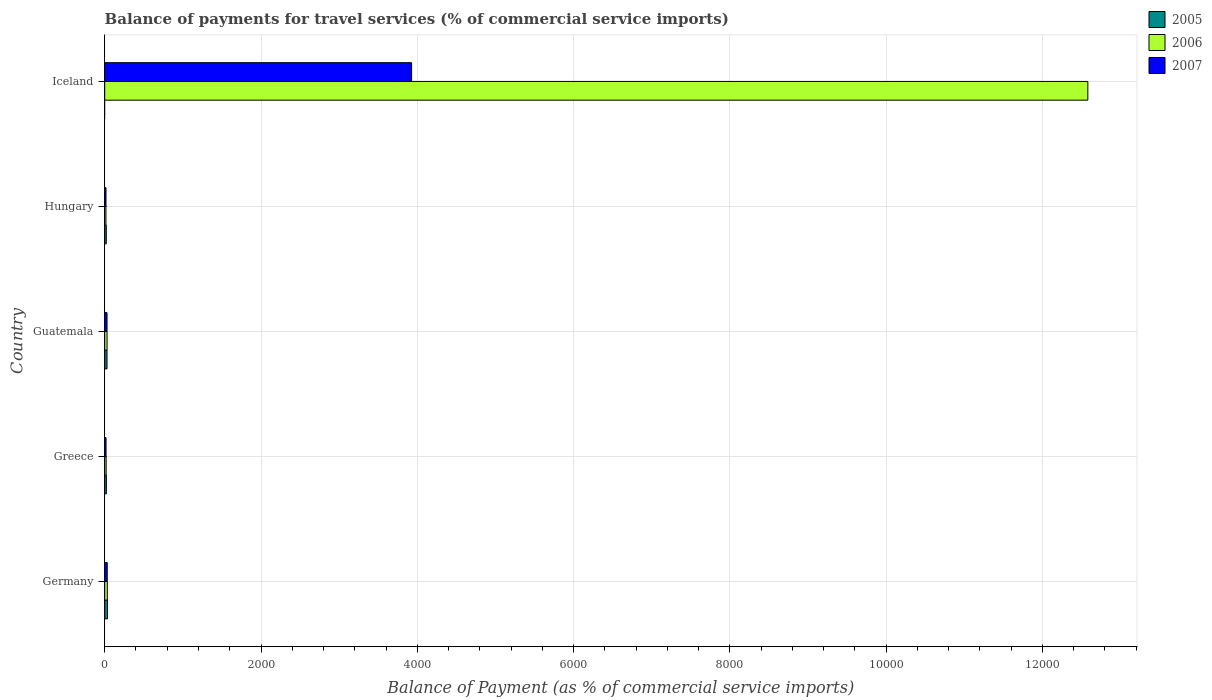How many groups of bars are there?
Offer a very short reply. 5. How many bars are there on the 2nd tick from the top?
Offer a terse response. 3. In how many cases, is the number of bars for a given country not equal to the number of legend labels?
Offer a very short reply. 1. What is the balance of payments for travel services in 2005 in Greece?
Keep it short and to the point. 21.01. Across all countries, what is the maximum balance of payments for travel services in 2005?
Keep it short and to the point. 35.65. What is the total balance of payments for travel services in 2007 in the graph?
Ensure brevity in your answer.  4022.27. What is the difference between the balance of payments for travel services in 2007 in Guatemala and that in Hungary?
Provide a short and direct response. 13.29. What is the difference between the balance of payments for travel services in 2006 in Germany and the balance of payments for travel services in 2007 in Iceland?
Make the answer very short. -3893.86. What is the average balance of payments for travel services in 2007 per country?
Provide a short and direct response. 804.45. What is the difference between the balance of payments for travel services in 2006 and balance of payments for travel services in 2007 in Greece?
Offer a terse response. 1.38. In how many countries, is the balance of payments for travel services in 2005 greater than 800 %?
Your response must be concise. 0. What is the ratio of the balance of payments for travel services in 2007 in Guatemala to that in Hungary?
Make the answer very short. 1.81. Is the difference between the balance of payments for travel services in 2006 in Guatemala and Iceland greater than the difference between the balance of payments for travel services in 2007 in Guatemala and Iceland?
Your answer should be very brief. No. What is the difference between the highest and the second highest balance of payments for travel services in 2005?
Your response must be concise. 6.2. What is the difference between the highest and the lowest balance of payments for travel services in 2007?
Make the answer very short. 3910.73. In how many countries, is the balance of payments for travel services in 2007 greater than the average balance of payments for travel services in 2007 taken over all countries?
Provide a succinct answer. 1. Is it the case that in every country, the sum of the balance of payments for travel services in 2005 and balance of payments for travel services in 2007 is greater than the balance of payments for travel services in 2006?
Provide a succinct answer. No. Are all the bars in the graph horizontal?
Offer a terse response. Yes. How many countries are there in the graph?
Your response must be concise. 5. Does the graph contain any zero values?
Your answer should be very brief. Yes. Where does the legend appear in the graph?
Your answer should be compact. Top right. How are the legend labels stacked?
Give a very brief answer. Vertical. What is the title of the graph?
Your answer should be compact. Balance of payments for travel services (% of commercial service imports). Does "1988" appear as one of the legend labels in the graph?
Give a very brief answer. No. What is the label or title of the X-axis?
Offer a terse response. Balance of Payment (as % of commercial service imports). What is the label or title of the Y-axis?
Your answer should be compact. Country. What is the Balance of Payment (as % of commercial service imports) in 2005 in Germany?
Your answer should be compact. 35.65. What is the Balance of Payment (as % of commercial service imports) in 2006 in Germany?
Provide a succinct answer. 33.19. What is the Balance of Payment (as % of commercial service imports) of 2007 in Germany?
Keep it short and to the point. 32.28. What is the Balance of Payment (as % of commercial service imports) in 2005 in Greece?
Offer a very short reply. 21.01. What is the Balance of Payment (as % of commercial service imports) in 2006 in Greece?
Give a very brief answer. 18.4. What is the Balance of Payment (as % of commercial service imports) of 2007 in Greece?
Offer a very short reply. 17.02. What is the Balance of Payment (as % of commercial service imports) in 2005 in Guatemala?
Ensure brevity in your answer.  29.45. What is the Balance of Payment (as % of commercial service imports) in 2006 in Guatemala?
Provide a succinct answer. 30.09. What is the Balance of Payment (as % of commercial service imports) of 2007 in Guatemala?
Offer a very short reply. 29.61. What is the Balance of Payment (as % of commercial service imports) of 2005 in Hungary?
Ensure brevity in your answer.  20.04. What is the Balance of Payment (as % of commercial service imports) of 2006 in Hungary?
Your response must be concise. 15.72. What is the Balance of Payment (as % of commercial service imports) in 2007 in Hungary?
Ensure brevity in your answer.  16.32. What is the Balance of Payment (as % of commercial service imports) in 2005 in Iceland?
Ensure brevity in your answer.  0. What is the Balance of Payment (as % of commercial service imports) of 2006 in Iceland?
Provide a succinct answer. 1.26e+04. What is the Balance of Payment (as % of commercial service imports) of 2007 in Iceland?
Ensure brevity in your answer.  3927.05. Across all countries, what is the maximum Balance of Payment (as % of commercial service imports) in 2005?
Your answer should be compact. 35.65. Across all countries, what is the maximum Balance of Payment (as % of commercial service imports) of 2006?
Your response must be concise. 1.26e+04. Across all countries, what is the maximum Balance of Payment (as % of commercial service imports) in 2007?
Your response must be concise. 3927.05. Across all countries, what is the minimum Balance of Payment (as % of commercial service imports) of 2006?
Provide a short and direct response. 15.72. Across all countries, what is the minimum Balance of Payment (as % of commercial service imports) in 2007?
Give a very brief answer. 16.32. What is the total Balance of Payment (as % of commercial service imports) of 2005 in the graph?
Provide a short and direct response. 106.16. What is the total Balance of Payment (as % of commercial service imports) in 2006 in the graph?
Provide a short and direct response. 1.27e+04. What is the total Balance of Payment (as % of commercial service imports) in 2007 in the graph?
Your answer should be compact. 4022.27. What is the difference between the Balance of Payment (as % of commercial service imports) in 2005 in Germany and that in Greece?
Your answer should be very brief. 14.64. What is the difference between the Balance of Payment (as % of commercial service imports) of 2006 in Germany and that in Greece?
Ensure brevity in your answer.  14.79. What is the difference between the Balance of Payment (as % of commercial service imports) of 2007 in Germany and that in Greece?
Your response must be concise. 15.27. What is the difference between the Balance of Payment (as % of commercial service imports) in 2005 in Germany and that in Guatemala?
Your answer should be compact. 6.2. What is the difference between the Balance of Payment (as % of commercial service imports) of 2006 in Germany and that in Guatemala?
Provide a short and direct response. 3.1. What is the difference between the Balance of Payment (as % of commercial service imports) of 2007 in Germany and that in Guatemala?
Provide a succinct answer. 2.67. What is the difference between the Balance of Payment (as % of commercial service imports) in 2005 in Germany and that in Hungary?
Keep it short and to the point. 15.61. What is the difference between the Balance of Payment (as % of commercial service imports) of 2006 in Germany and that in Hungary?
Provide a succinct answer. 17.47. What is the difference between the Balance of Payment (as % of commercial service imports) in 2007 in Germany and that in Hungary?
Keep it short and to the point. 15.97. What is the difference between the Balance of Payment (as % of commercial service imports) of 2006 in Germany and that in Iceland?
Provide a short and direct response. -1.25e+04. What is the difference between the Balance of Payment (as % of commercial service imports) in 2007 in Germany and that in Iceland?
Keep it short and to the point. -3894.76. What is the difference between the Balance of Payment (as % of commercial service imports) in 2005 in Greece and that in Guatemala?
Your response must be concise. -8.44. What is the difference between the Balance of Payment (as % of commercial service imports) of 2006 in Greece and that in Guatemala?
Ensure brevity in your answer.  -11.69. What is the difference between the Balance of Payment (as % of commercial service imports) of 2007 in Greece and that in Guatemala?
Offer a terse response. -12.59. What is the difference between the Balance of Payment (as % of commercial service imports) in 2005 in Greece and that in Hungary?
Offer a very short reply. 0.97. What is the difference between the Balance of Payment (as % of commercial service imports) of 2006 in Greece and that in Hungary?
Provide a succinct answer. 2.68. What is the difference between the Balance of Payment (as % of commercial service imports) in 2007 in Greece and that in Hungary?
Your response must be concise. 0.7. What is the difference between the Balance of Payment (as % of commercial service imports) of 2006 in Greece and that in Iceland?
Your answer should be compact. -1.26e+04. What is the difference between the Balance of Payment (as % of commercial service imports) in 2007 in Greece and that in Iceland?
Make the answer very short. -3910.03. What is the difference between the Balance of Payment (as % of commercial service imports) in 2005 in Guatemala and that in Hungary?
Provide a succinct answer. 9.41. What is the difference between the Balance of Payment (as % of commercial service imports) of 2006 in Guatemala and that in Hungary?
Your answer should be compact. 14.37. What is the difference between the Balance of Payment (as % of commercial service imports) in 2007 in Guatemala and that in Hungary?
Provide a short and direct response. 13.29. What is the difference between the Balance of Payment (as % of commercial service imports) of 2006 in Guatemala and that in Iceland?
Give a very brief answer. -1.26e+04. What is the difference between the Balance of Payment (as % of commercial service imports) of 2007 in Guatemala and that in Iceland?
Offer a very short reply. -3897.44. What is the difference between the Balance of Payment (as % of commercial service imports) in 2006 in Hungary and that in Iceland?
Your response must be concise. -1.26e+04. What is the difference between the Balance of Payment (as % of commercial service imports) in 2007 in Hungary and that in Iceland?
Provide a succinct answer. -3910.73. What is the difference between the Balance of Payment (as % of commercial service imports) in 2005 in Germany and the Balance of Payment (as % of commercial service imports) in 2006 in Greece?
Provide a short and direct response. 17.25. What is the difference between the Balance of Payment (as % of commercial service imports) in 2005 in Germany and the Balance of Payment (as % of commercial service imports) in 2007 in Greece?
Ensure brevity in your answer.  18.63. What is the difference between the Balance of Payment (as % of commercial service imports) in 2006 in Germany and the Balance of Payment (as % of commercial service imports) in 2007 in Greece?
Your answer should be compact. 16.17. What is the difference between the Balance of Payment (as % of commercial service imports) of 2005 in Germany and the Balance of Payment (as % of commercial service imports) of 2006 in Guatemala?
Keep it short and to the point. 5.56. What is the difference between the Balance of Payment (as % of commercial service imports) of 2005 in Germany and the Balance of Payment (as % of commercial service imports) of 2007 in Guatemala?
Your answer should be very brief. 6.04. What is the difference between the Balance of Payment (as % of commercial service imports) of 2006 in Germany and the Balance of Payment (as % of commercial service imports) of 2007 in Guatemala?
Keep it short and to the point. 3.58. What is the difference between the Balance of Payment (as % of commercial service imports) of 2005 in Germany and the Balance of Payment (as % of commercial service imports) of 2006 in Hungary?
Your answer should be compact. 19.93. What is the difference between the Balance of Payment (as % of commercial service imports) in 2005 in Germany and the Balance of Payment (as % of commercial service imports) in 2007 in Hungary?
Offer a very short reply. 19.34. What is the difference between the Balance of Payment (as % of commercial service imports) in 2006 in Germany and the Balance of Payment (as % of commercial service imports) in 2007 in Hungary?
Make the answer very short. 16.87. What is the difference between the Balance of Payment (as % of commercial service imports) in 2005 in Germany and the Balance of Payment (as % of commercial service imports) in 2006 in Iceland?
Your answer should be compact. -1.25e+04. What is the difference between the Balance of Payment (as % of commercial service imports) in 2005 in Germany and the Balance of Payment (as % of commercial service imports) in 2007 in Iceland?
Offer a very short reply. -3891.4. What is the difference between the Balance of Payment (as % of commercial service imports) of 2006 in Germany and the Balance of Payment (as % of commercial service imports) of 2007 in Iceland?
Make the answer very short. -3893.86. What is the difference between the Balance of Payment (as % of commercial service imports) of 2005 in Greece and the Balance of Payment (as % of commercial service imports) of 2006 in Guatemala?
Ensure brevity in your answer.  -9.08. What is the difference between the Balance of Payment (as % of commercial service imports) in 2005 in Greece and the Balance of Payment (as % of commercial service imports) in 2007 in Guatemala?
Provide a succinct answer. -8.6. What is the difference between the Balance of Payment (as % of commercial service imports) of 2006 in Greece and the Balance of Payment (as % of commercial service imports) of 2007 in Guatemala?
Your response must be concise. -11.21. What is the difference between the Balance of Payment (as % of commercial service imports) of 2005 in Greece and the Balance of Payment (as % of commercial service imports) of 2006 in Hungary?
Give a very brief answer. 5.29. What is the difference between the Balance of Payment (as % of commercial service imports) of 2005 in Greece and the Balance of Payment (as % of commercial service imports) of 2007 in Hungary?
Your answer should be very brief. 4.69. What is the difference between the Balance of Payment (as % of commercial service imports) in 2006 in Greece and the Balance of Payment (as % of commercial service imports) in 2007 in Hungary?
Your response must be concise. 2.08. What is the difference between the Balance of Payment (as % of commercial service imports) of 2005 in Greece and the Balance of Payment (as % of commercial service imports) of 2006 in Iceland?
Provide a short and direct response. -1.26e+04. What is the difference between the Balance of Payment (as % of commercial service imports) in 2005 in Greece and the Balance of Payment (as % of commercial service imports) in 2007 in Iceland?
Keep it short and to the point. -3906.04. What is the difference between the Balance of Payment (as % of commercial service imports) of 2006 in Greece and the Balance of Payment (as % of commercial service imports) of 2007 in Iceland?
Keep it short and to the point. -3908.65. What is the difference between the Balance of Payment (as % of commercial service imports) of 2005 in Guatemala and the Balance of Payment (as % of commercial service imports) of 2006 in Hungary?
Offer a very short reply. 13.73. What is the difference between the Balance of Payment (as % of commercial service imports) in 2005 in Guatemala and the Balance of Payment (as % of commercial service imports) in 2007 in Hungary?
Your answer should be very brief. 13.13. What is the difference between the Balance of Payment (as % of commercial service imports) of 2006 in Guatemala and the Balance of Payment (as % of commercial service imports) of 2007 in Hungary?
Your response must be concise. 13.77. What is the difference between the Balance of Payment (as % of commercial service imports) in 2005 in Guatemala and the Balance of Payment (as % of commercial service imports) in 2006 in Iceland?
Ensure brevity in your answer.  -1.26e+04. What is the difference between the Balance of Payment (as % of commercial service imports) of 2005 in Guatemala and the Balance of Payment (as % of commercial service imports) of 2007 in Iceland?
Keep it short and to the point. -3897.6. What is the difference between the Balance of Payment (as % of commercial service imports) in 2006 in Guatemala and the Balance of Payment (as % of commercial service imports) in 2007 in Iceland?
Give a very brief answer. -3896.96. What is the difference between the Balance of Payment (as % of commercial service imports) of 2005 in Hungary and the Balance of Payment (as % of commercial service imports) of 2006 in Iceland?
Offer a terse response. -1.26e+04. What is the difference between the Balance of Payment (as % of commercial service imports) in 2005 in Hungary and the Balance of Payment (as % of commercial service imports) in 2007 in Iceland?
Your answer should be compact. -3907.01. What is the difference between the Balance of Payment (as % of commercial service imports) in 2006 in Hungary and the Balance of Payment (as % of commercial service imports) in 2007 in Iceland?
Keep it short and to the point. -3911.32. What is the average Balance of Payment (as % of commercial service imports) of 2005 per country?
Offer a terse response. 21.23. What is the average Balance of Payment (as % of commercial service imports) in 2006 per country?
Your response must be concise. 2535.76. What is the average Balance of Payment (as % of commercial service imports) of 2007 per country?
Offer a terse response. 804.45. What is the difference between the Balance of Payment (as % of commercial service imports) of 2005 and Balance of Payment (as % of commercial service imports) of 2006 in Germany?
Ensure brevity in your answer.  2.46. What is the difference between the Balance of Payment (as % of commercial service imports) in 2005 and Balance of Payment (as % of commercial service imports) in 2007 in Germany?
Ensure brevity in your answer.  3.37. What is the difference between the Balance of Payment (as % of commercial service imports) in 2006 and Balance of Payment (as % of commercial service imports) in 2007 in Germany?
Keep it short and to the point. 0.91. What is the difference between the Balance of Payment (as % of commercial service imports) in 2005 and Balance of Payment (as % of commercial service imports) in 2006 in Greece?
Offer a terse response. 2.61. What is the difference between the Balance of Payment (as % of commercial service imports) of 2005 and Balance of Payment (as % of commercial service imports) of 2007 in Greece?
Offer a very short reply. 3.99. What is the difference between the Balance of Payment (as % of commercial service imports) of 2006 and Balance of Payment (as % of commercial service imports) of 2007 in Greece?
Keep it short and to the point. 1.38. What is the difference between the Balance of Payment (as % of commercial service imports) of 2005 and Balance of Payment (as % of commercial service imports) of 2006 in Guatemala?
Your answer should be compact. -0.64. What is the difference between the Balance of Payment (as % of commercial service imports) in 2005 and Balance of Payment (as % of commercial service imports) in 2007 in Guatemala?
Give a very brief answer. -0.16. What is the difference between the Balance of Payment (as % of commercial service imports) of 2006 and Balance of Payment (as % of commercial service imports) of 2007 in Guatemala?
Give a very brief answer. 0.48. What is the difference between the Balance of Payment (as % of commercial service imports) of 2005 and Balance of Payment (as % of commercial service imports) of 2006 in Hungary?
Provide a succinct answer. 4.32. What is the difference between the Balance of Payment (as % of commercial service imports) of 2005 and Balance of Payment (as % of commercial service imports) of 2007 in Hungary?
Provide a succinct answer. 3.73. What is the difference between the Balance of Payment (as % of commercial service imports) in 2006 and Balance of Payment (as % of commercial service imports) in 2007 in Hungary?
Make the answer very short. -0.59. What is the difference between the Balance of Payment (as % of commercial service imports) in 2006 and Balance of Payment (as % of commercial service imports) in 2007 in Iceland?
Offer a very short reply. 8654.34. What is the ratio of the Balance of Payment (as % of commercial service imports) of 2005 in Germany to that in Greece?
Ensure brevity in your answer.  1.7. What is the ratio of the Balance of Payment (as % of commercial service imports) of 2006 in Germany to that in Greece?
Your response must be concise. 1.8. What is the ratio of the Balance of Payment (as % of commercial service imports) of 2007 in Germany to that in Greece?
Provide a succinct answer. 1.9. What is the ratio of the Balance of Payment (as % of commercial service imports) in 2005 in Germany to that in Guatemala?
Keep it short and to the point. 1.21. What is the ratio of the Balance of Payment (as % of commercial service imports) of 2006 in Germany to that in Guatemala?
Offer a very short reply. 1.1. What is the ratio of the Balance of Payment (as % of commercial service imports) of 2007 in Germany to that in Guatemala?
Offer a very short reply. 1.09. What is the ratio of the Balance of Payment (as % of commercial service imports) of 2005 in Germany to that in Hungary?
Your answer should be very brief. 1.78. What is the ratio of the Balance of Payment (as % of commercial service imports) of 2006 in Germany to that in Hungary?
Provide a succinct answer. 2.11. What is the ratio of the Balance of Payment (as % of commercial service imports) of 2007 in Germany to that in Hungary?
Your answer should be compact. 1.98. What is the ratio of the Balance of Payment (as % of commercial service imports) in 2006 in Germany to that in Iceland?
Ensure brevity in your answer.  0. What is the ratio of the Balance of Payment (as % of commercial service imports) in 2007 in Germany to that in Iceland?
Provide a succinct answer. 0.01. What is the ratio of the Balance of Payment (as % of commercial service imports) of 2005 in Greece to that in Guatemala?
Offer a very short reply. 0.71. What is the ratio of the Balance of Payment (as % of commercial service imports) in 2006 in Greece to that in Guatemala?
Your answer should be very brief. 0.61. What is the ratio of the Balance of Payment (as % of commercial service imports) of 2007 in Greece to that in Guatemala?
Your answer should be compact. 0.57. What is the ratio of the Balance of Payment (as % of commercial service imports) of 2005 in Greece to that in Hungary?
Give a very brief answer. 1.05. What is the ratio of the Balance of Payment (as % of commercial service imports) in 2006 in Greece to that in Hungary?
Your response must be concise. 1.17. What is the ratio of the Balance of Payment (as % of commercial service imports) in 2007 in Greece to that in Hungary?
Ensure brevity in your answer.  1.04. What is the ratio of the Balance of Payment (as % of commercial service imports) in 2006 in Greece to that in Iceland?
Ensure brevity in your answer.  0. What is the ratio of the Balance of Payment (as % of commercial service imports) in 2007 in Greece to that in Iceland?
Your answer should be compact. 0. What is the ratio of the Balance of Payment (as % of commercial service imports) in 2005 in Guatemala to that in Hungary?
Offer a terse response. 1.47. What is the ratio of the Balance of Payment (as % of commercial service imports) in 2006 in Guatemala to that in Hungary?
Offer a very short reply. 1.91. What is the ratio of the Balance of Payment (as % of commercial service imports) of 2007 in Guatemala to that in Hungary?
Provide a succinct answer. 1.81. What is the ratio of the Balance of Payment (as % of commercial service imports) in 2006 in Guatemala to that in Iceland?
Your answer should be very brief. 0. What is the ratio of the Balance of Payment (as % of commercial service imports) in 2007 in Guatemala to that in Iceland?
Make the answer very short. 0.01. What is the ratio of the Balance of Payment (as % of commercial service imports) of 2006 in Hungary to that in Iceland?
Give a very brief answer. 0. What is the ratio of the Balance of Payment (as % of commercial service imports) of 2007 in Hungary to that in Iceland?
Offer a terse response. 0. What is the difference between the highest and the second highest Balance of Payment (as % of commercial service imports) of 2005?
Keep it short and to the point. 6.2. What is the difference between the highest and the second highest Balance of Payment (as % of commercial service imports) of 2006?
Offer a very short reply. 1.25e+04. What is the difference between the highest and the second highest Balance of Payment (as % of commercial service imports) in 2007?
Provide a succinct answer. 3894.76. What is the difference between the highest and the lowest Balance of Payment (as % of commercial service imports) in 2005?
Make the answer very short. 35.65. What is the difference between the highest and the lowest Balance of Payment (as % of commercial service imports) in 2006?
Your answer should be compact. 1.26e+04. What is the difference between the highest and the lowest Balance of Payment (as % of commercial service imports) of 2007?
Your response must be concise. 3910.73. 